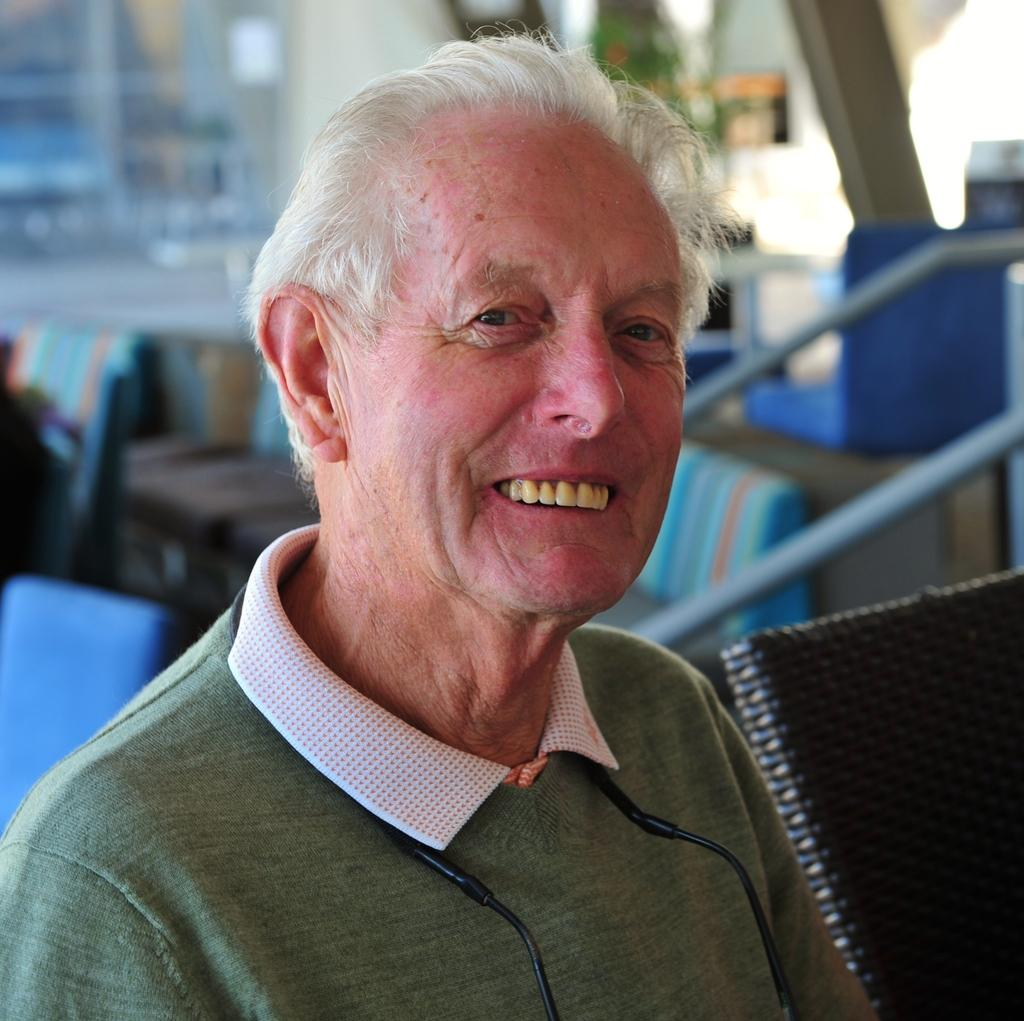What is present in the image? There is a person in the image. How is the person's expression in the image? The person is smiling. What can be seen in the background of the image? There is a chair in the background of the image. What is the name of the person in the image? The provided facts do not mention the name of the person in the image, so we cannot determine their name from the information given. 